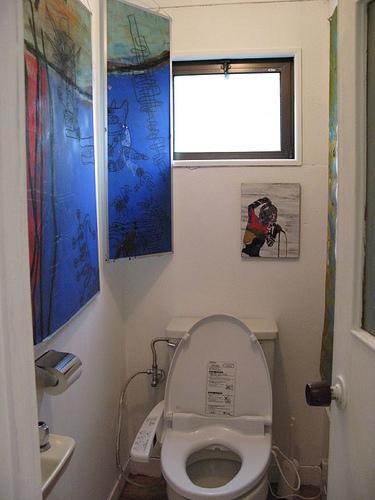Is the window open?
Write a very short answer. No. Is the toilet seat up?
Be succinct. Yes. Could someone see the bathtub from the window?
Keep it brief. No. How many toilets are in this picture?
Short answer required. 1. Is there a picture above the toilet?
Be succinct. Yes. How many windows are shown?
Short answer required. 1. 